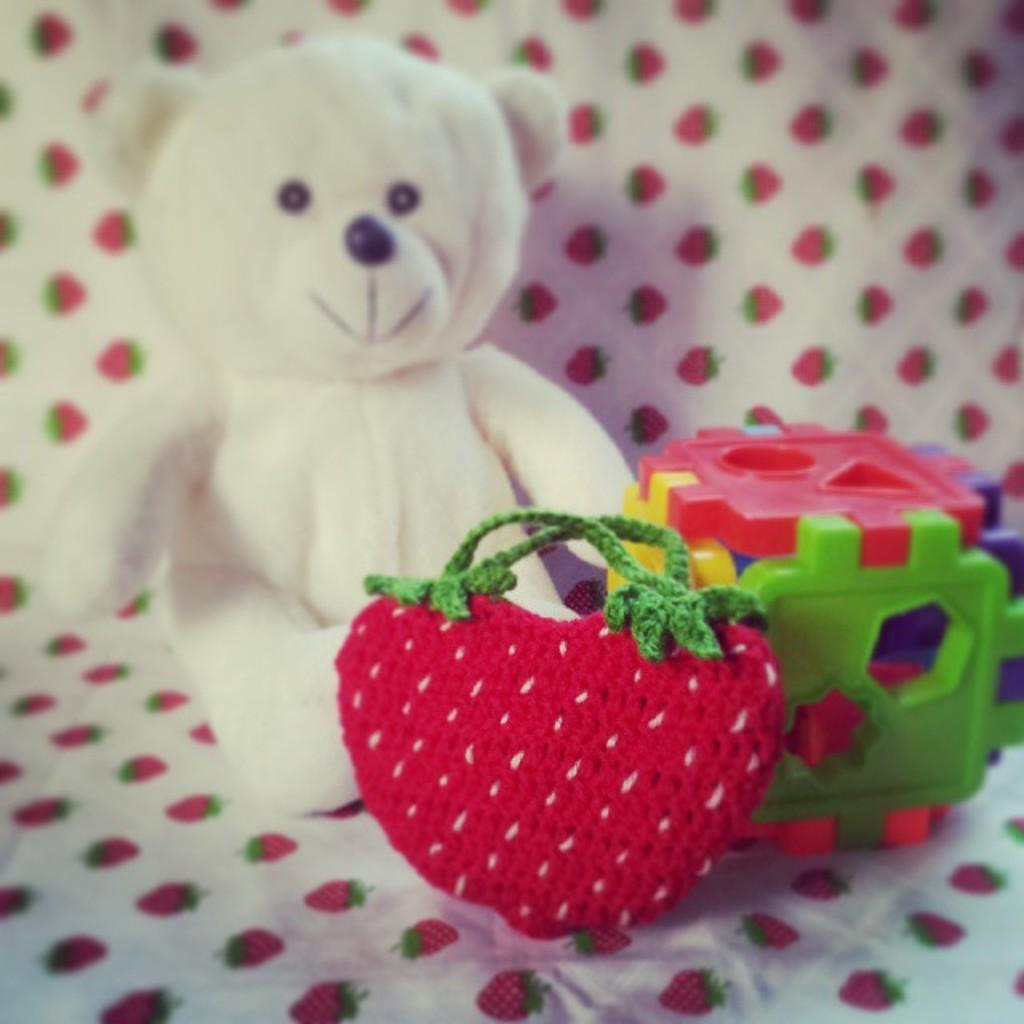What type of object can be seen in the image? There is a teddy in the image. What else is present in the image besides the teddy? There are toys in the image. How are the toys arranged in the image? The toys are placed on a cloth. What type of brass instrument is being played by the teddy in the image? There is no brass instrument present in the image, and the teddy is not playing any instrument. 